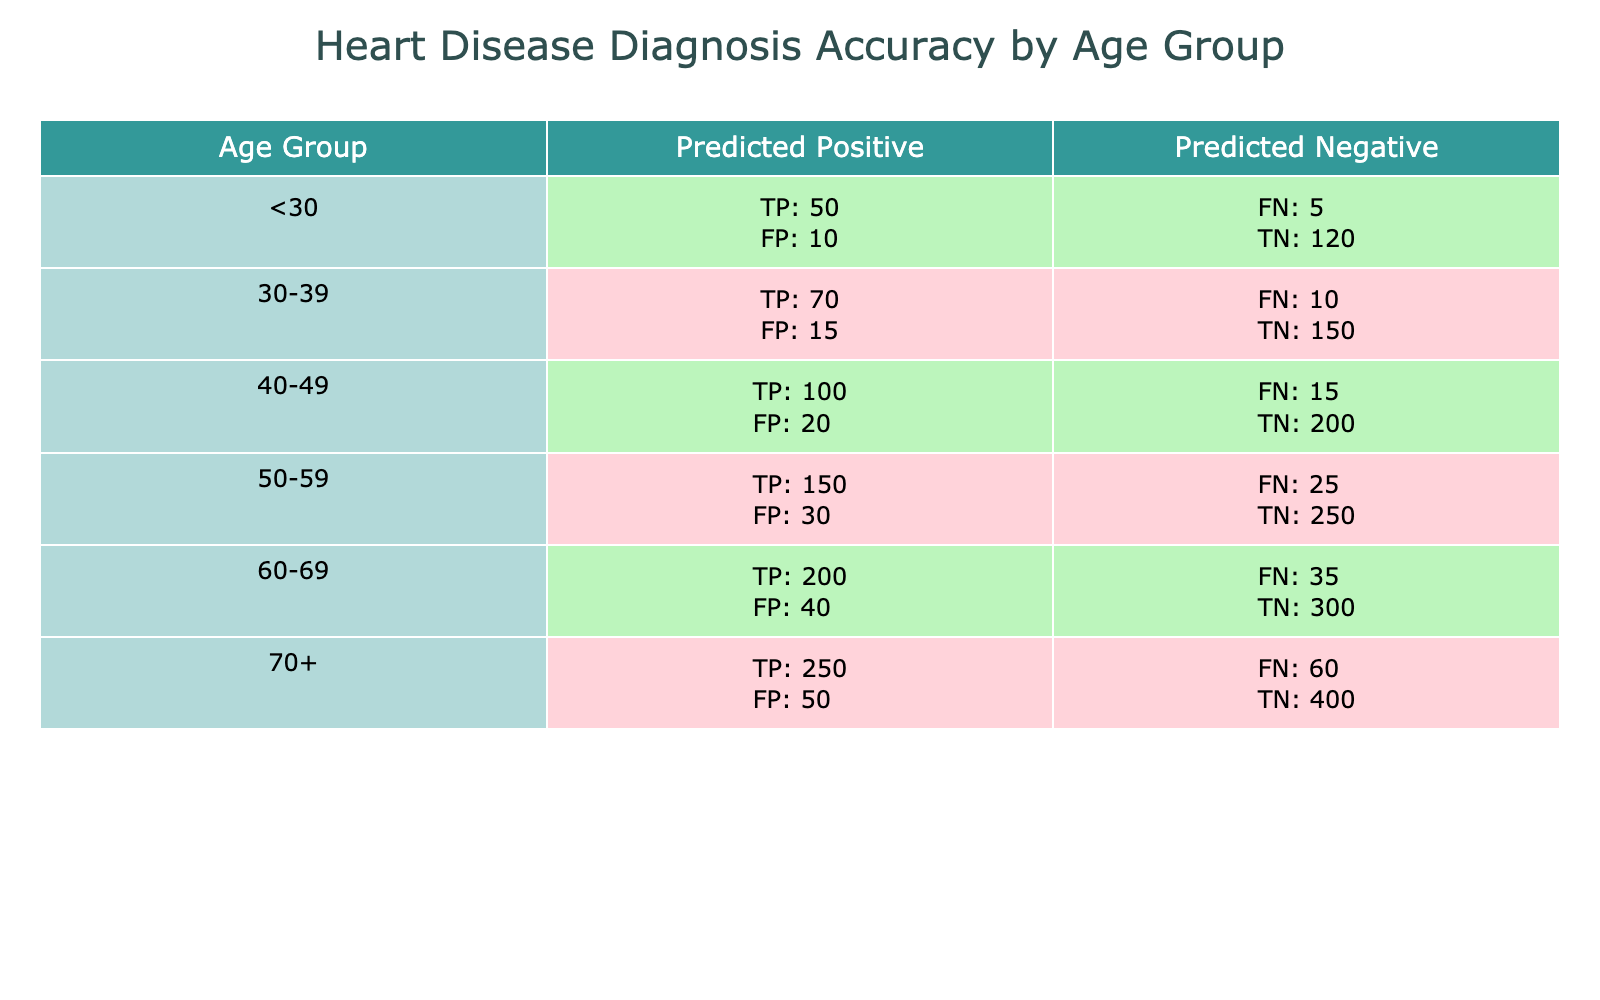What is the true positive count for the 50-59 age group? In the table for the 50-59 age group, the true positive count is listed as 150.
Answer: 150 What is the number of false negatives for the 60-69 age group? Referring to the 60-69 age group in the table, the false negative count is 35.
Answer: 35 Which age group has the highest number of true negatives? By reviewing all age groups, the 70+ age group has the highest true negative count of 400.
Answer: 400 What is the total number of true positives across all age groups? The true positives across all age groups can be summed as follows: 50 + 70 + 100 + 150 + 200 + 250 = 820.
Answer: 820 Is the false positive count for the 40-49 age group greater than the false negative count? The false positive count for the 40-49 age group is 20 and the false negative count is 15, which means 20 is greater than 15. Therefore, the statement is true.
Answer: Yes What is the average number of true negatives for the age groups aged 30 and above? The true negatives for the age groups of 30-39, 40-49, 50-59, 60-69, and 70+ are 150, 200, 250, 300, and 400 respectively. Summing these gives 1300, and since there are 5 age groups, the average is 1300 / 5 = 260.
Answer: 260 If we combine the false positives and false negatives for the 30-39 age group, what is the total? The false positive count for the 30-39 group is 15 and the false negative count is 10. Adding these together gives 15 + 10 = 25.
Answer: 25 What percentage of true positives does the 60-69 age group represent from the total true positives? The true positives for the 60-69 age group is 200 and the total true positives is 820. Therefore, the percentage is (200 / 820) * 100, which equals about 24.39%.
Answer: About 24.39% Which age group has the lowest sum of false positives and false negatives? By reviewing the sums for each age group, we find: <30: 10 + 5 = 15, 30-39: 15 + 10 = 25, 40-49: 20 + 15 = 35, 50-59: 30 + 25 = 55, 60-69: 40 + 35 = 75, 70+: 50 + 60 = 110. The lowest sum is for the <30 age group with a total of 15.
Answer: <30 